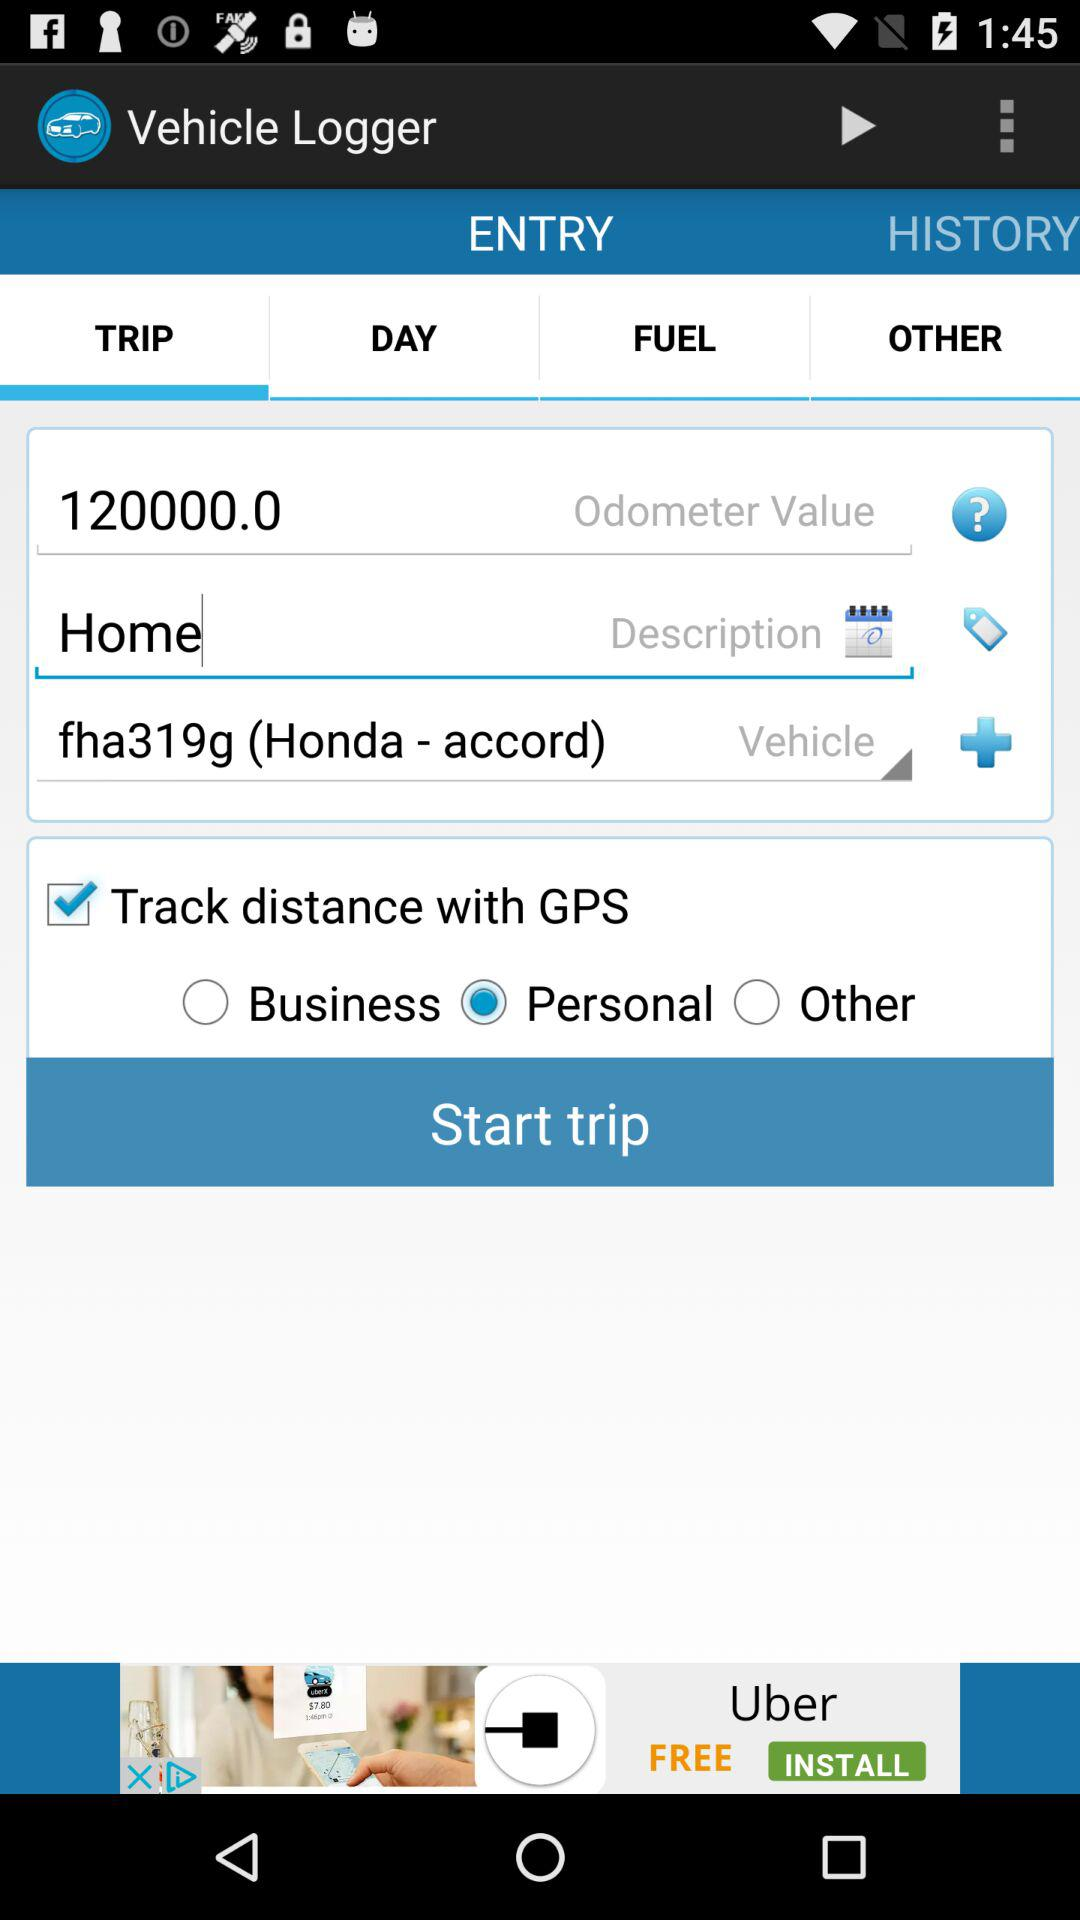What's the status of "Track distance with GPS"? The status of "Track distance with GPS" is "on". 